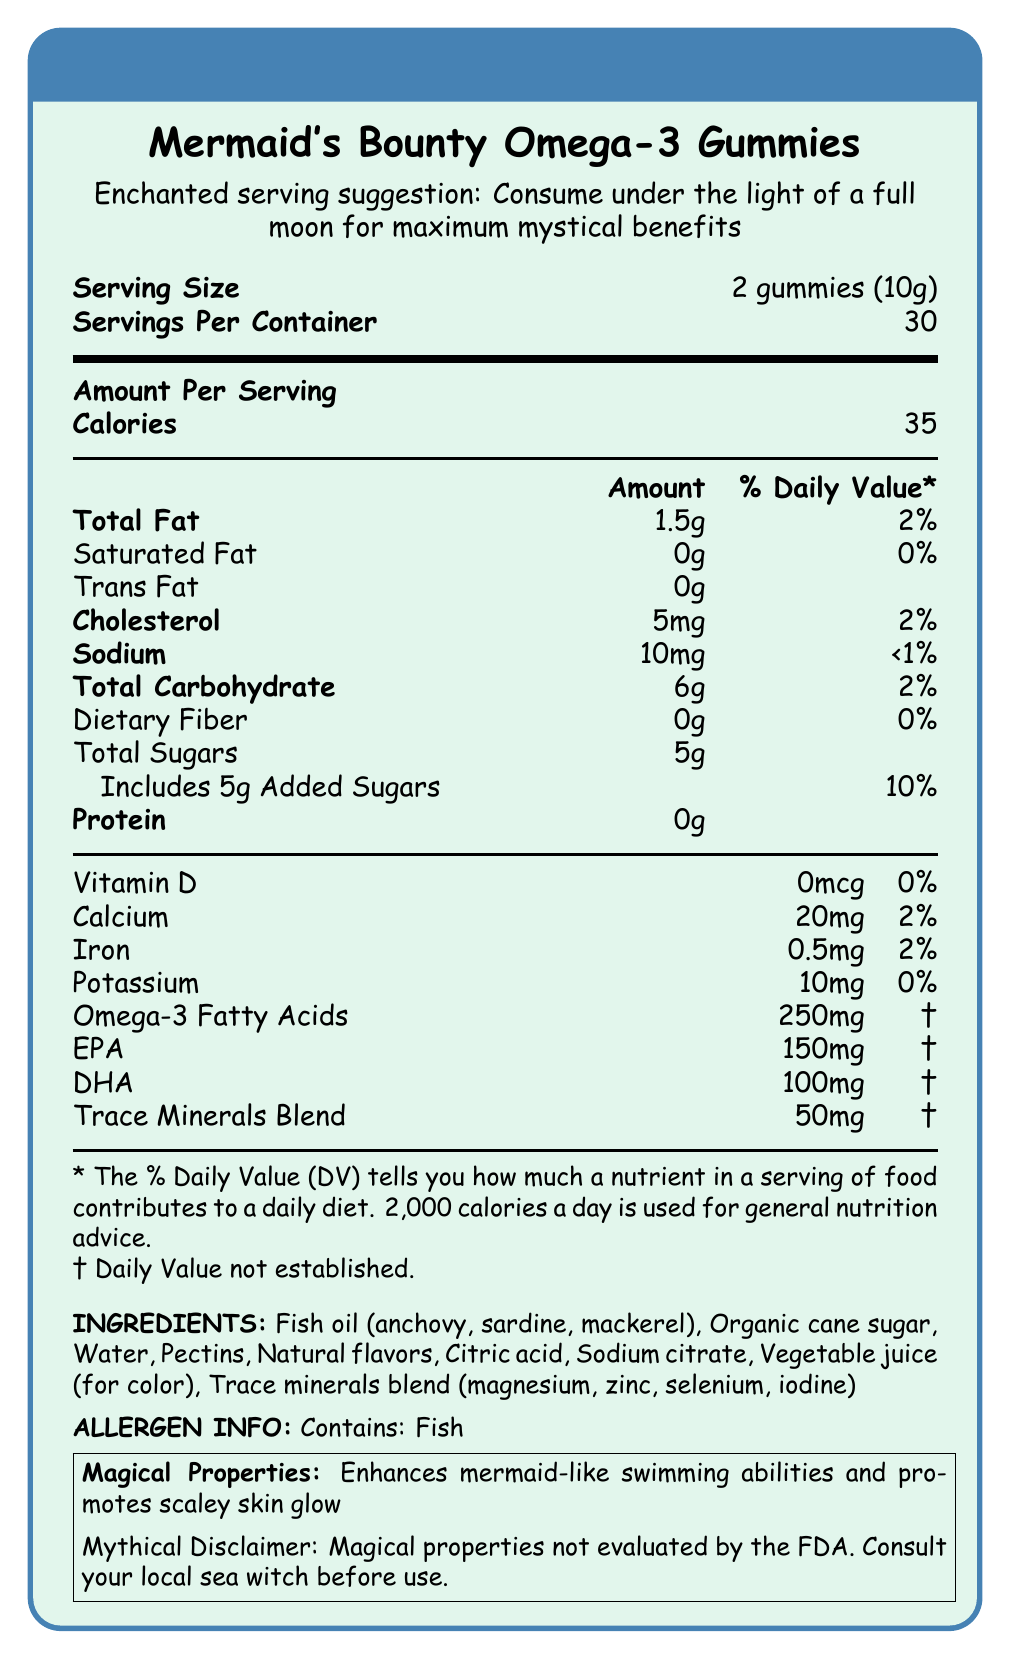What is the serving size for Mermaid's Bounty Omega-3 Gummies? The document specifies that the serving size is 2 gummies (10g).
Answer: 2 gummies (10g) How many calories are in one serving of these gummies? The document shows that each serving contains 35 calories.
Answer: 35 calories What percentage of the daily value for calcium is in one serving? The document lists that one serving has 2% of the daily value for calcium.
Answer: 2% Does the product contain any added sugars? According to the document, the product includes 5g of added sugars, which is 10% of the daily value.
Answer: Yes What are the omega-3 fatty acid components in the gummies and their amounts? The document specifies that the omega-3 fatty acids include 150mg of EPA and 100mg of DHA.
Answer: EPA: 150mg, DHA: 100mg Which magical property is promoted by these gummies? 
A. Enhances flight 
B. Improves night vision 
C. Enhances mermaid-like swimming abilities The document mentions that the gummies enhance mermaid-like swimming abilities.
Answer: C Which of the following ingredients is NOT listed in the document?
A. Fish oil 
B. Artificial flavors 
C. Organic cane sugar 
D. Citric acid The document lists all the other ingredients except for artificial flavors.
Answer: B Does the product contain any allergens? The document states that the product contains fish, which is an allergen.
Answer: Yes Describe the main idea of this document. The document contains various nutritional details and specific information on ingredients, allergens, and magical properties, offering a comprehensive look at the product.
Answer: This document provides detailed nutritional information for Mermaid's Bounty Omega-3 Gummies, including serving size, calories, fat content, vitamins, minerals, and magical properties. It also contains serving suggestions, ingredients, and allergens. How much protein is in one serving of the gummies? The document clearly states that there is 0g of protein in one serving.
Answer: 0g Which of the following trace minerals is NOT a part of the trace minerals blend in the gummies?
A. Magnesium
B. Zinc
C. Iron
D. Iodine The document lists magnesium, zinc, selenium, and iodine as part of the trace minerals blend. Iron is not included.
Answer: C Is the amount of total fat in one serving greater than the amount of total carbohydrate? The document shows that one serving has 1.5g of total fat and 6g of total carbohydrate.
Answer: No What is the daily value percentage of sodium in these gummies? The document indicates that the sodium content in one serving is 10mg, which is less than 1% of the daily value.
Answer: <1% Can we determine the total fiber content of these gummies? The document states that the dietary fiber content is 0g.
Answer: Yes What are the "magical properties" of the gummies based on the document? The document mentions these specific magical properties.
Answer: Enhances mermaid-like swimming abilities and promotes scaley skin glow Is it recommended by the FDA to consult a local sea witch before use of these gummies? The document humorously includes a mythical disclaimer saying to consult your local sea witch before use.
Answer: Yes Can we find out if these gummies have been evaluated by the FDA for their magical properties? The document states that the magical properties have not been evaluated by the FDA, indicating there isn't enough information for actual FDA evaluation.
Answer: No 